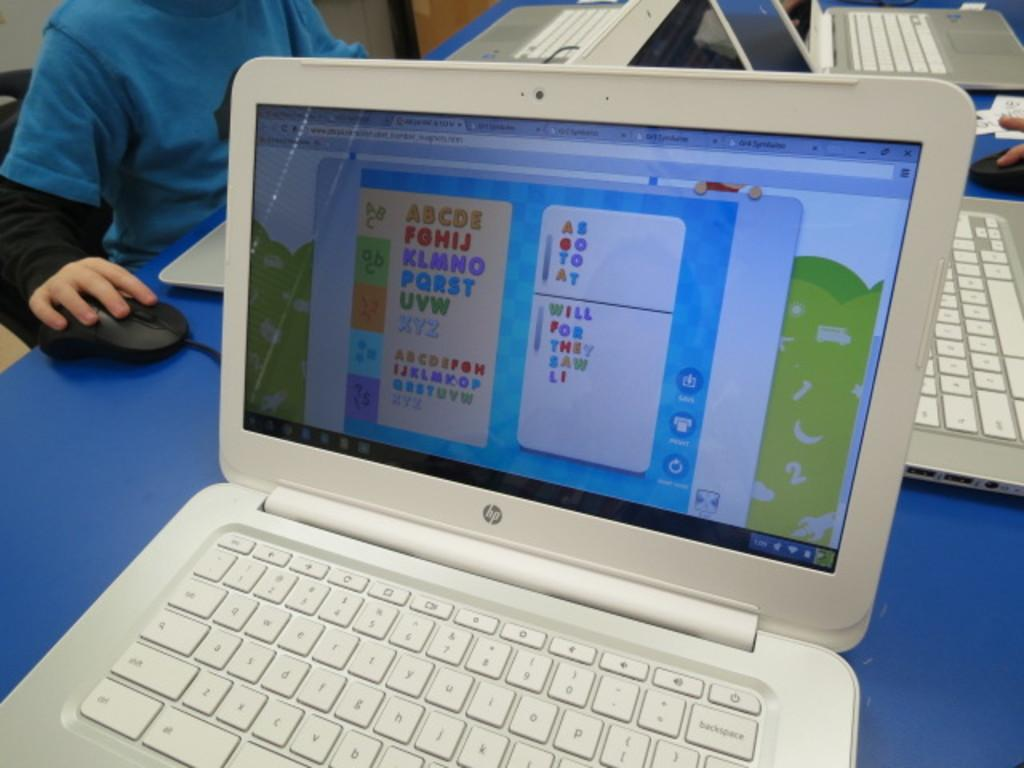Provide a one-sentence caption for the provided image. An open white colored HP laptop with an educational game on the screen. 